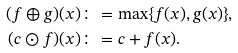Convert formula to latex. <formula><loc_0><loc_0><loc_500><loc_500>( f \oplus g ) ( x ) & \colon = \max \{ f ( x ) , g ( x ) \} , \\ ( c \odot f ) ( x ) & \colon = c + f ( x ) .</formula> 